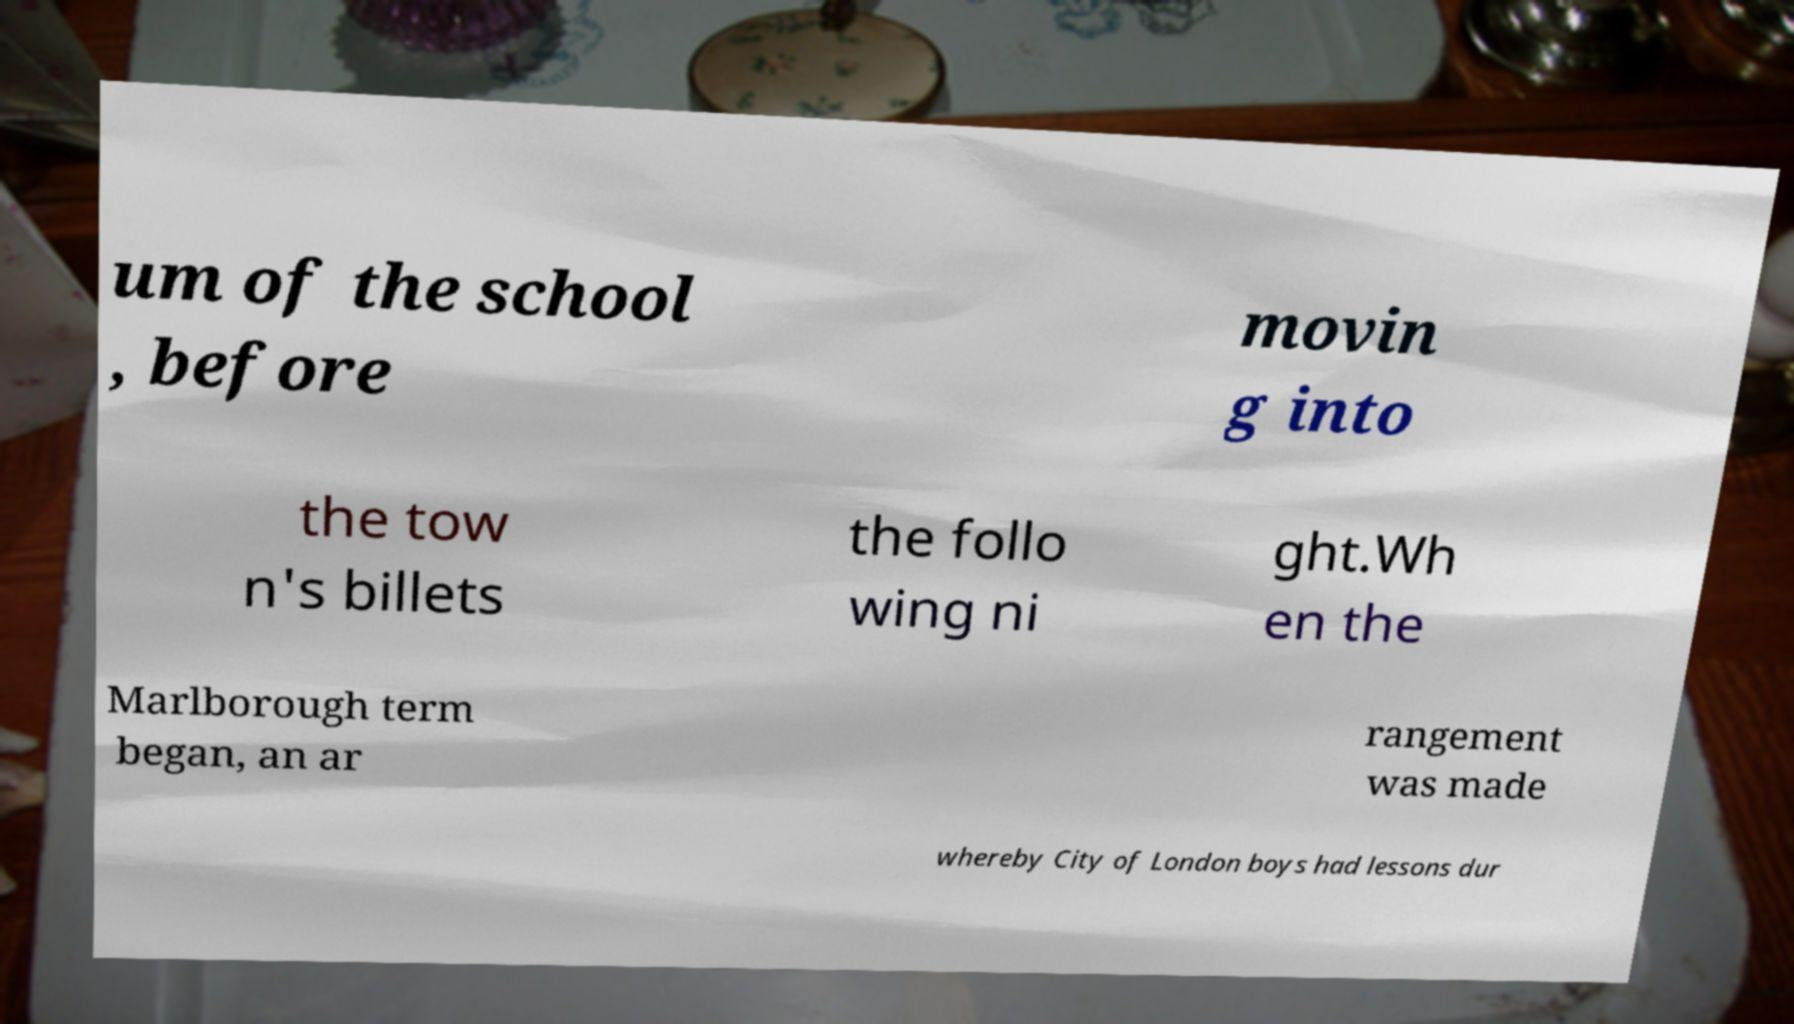I need the written content from this picture converted into text. Can you do that? um of the school , before movin g into the tow n's billets the follo wing ni ght.Wh en the Marlborough term began, an ar rangement was made whereby City of London boys had lessons dur 